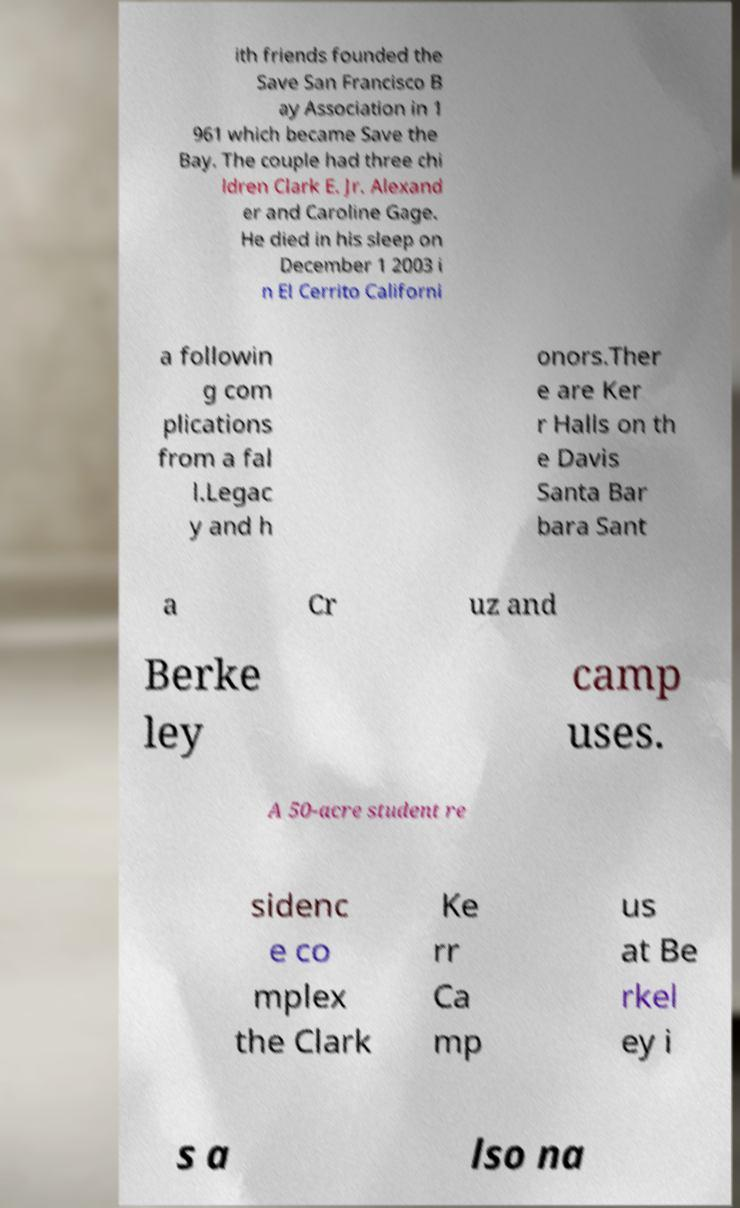For documentation purposes, I need the text within this image transcribed. Could you provide that? ith friends founded the Save San Francisco B ay Association in 1 961 which became Save the Bay. The couple had three chi ldren Clark E. Jr. Alexand er and Caroline Gage. He died in his sleep on December 1 2003 i n El Cerrito Californi a followin g com plications from a fal l.Legac y and h onors.Ther e are Ker r Halls on th e Davis Santa Bar bara Sant a Cr uz and Berke ley camp uses. A 50-acre student re sidenc e co mplex the Clark Ke rr Ca mp us at Be rkel ey i s a lso na 